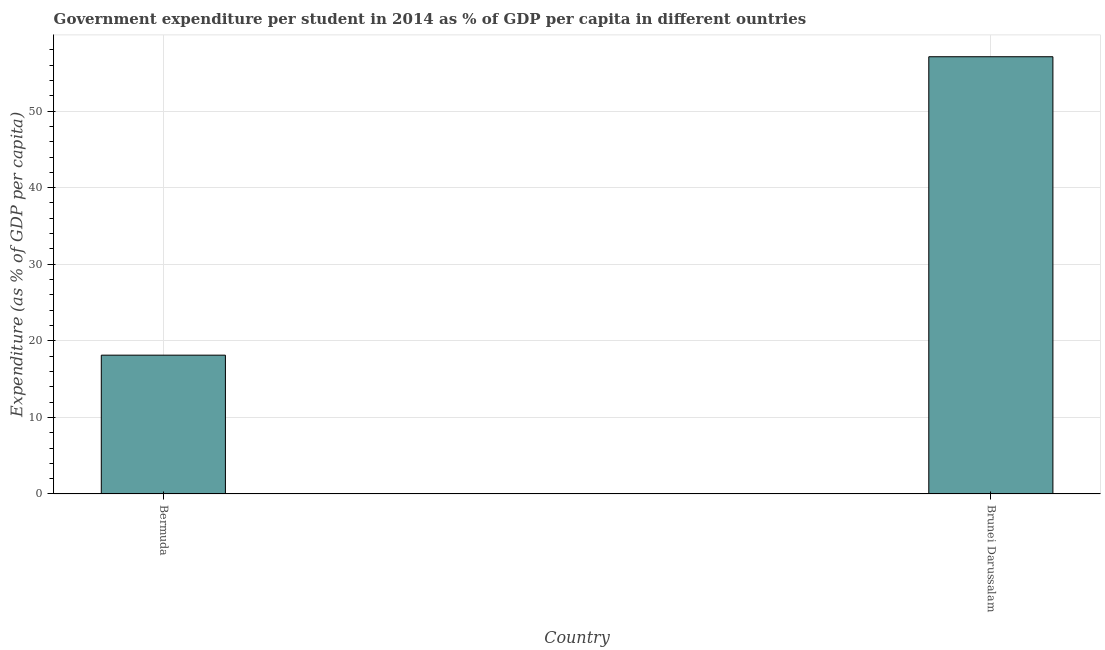Does the graph contain any zero values?
Your answer should be compact. No. What is the title of the graph?
Your response must be concise. Government expenditure per student in 2014 as % of GDP per capita in different ountries. What is the label or title of the Y-axis?
Offer a very short reply. Expenditure (as % of GDP per capita). What is the government expenditure per student in Brunei Darussalam?
Your response must be concise. 57.09. Across all countries, what is the maximum government expenditure per student?
Your answer should be very brief. 57.09. Across all countries, what is the minimum government expenditure per student?
Your response must be concise. 18.12. In which country was the government expenditure per student maximum?
Provide a short and direct response. Brunei Darussalam. In which country was the government expenditure per student minimum?
Keep it short and to the point. Bermuda. What is the sum of the government expenditure per student?
Make the answer very short. 75.22. What is the difference between the government expenditure per student in Bermuda and Brunei Darussalam?
Give a very brief answer. -38.97. What is the average government expenditure per student per country?
Your answer should be compact. 37.61. What is the median government expenditure per student?
Your answer should be very brief. 37.61. In how many countries, is the government expenditure per student greater than 14 %?
Your answer should be compact. 2. What is the ratio of the government expenditure per student in Bermuda to that in Brunei Darussalam?
Your answer should be very brief. 0.32. Is the government expenditure per student in Bermuda less than that in Brunei Darussalam?
Offer a terse response. Yes. How many bars are there?
Ensure brevity in your answer.  2. How many countries are there in the graph?
Your response must be concise. 2. Are the values on the major ticks of Y-axis written in scientific E-notation?
Give a very brief answer. No. What is the Expenditure (as % of GDP per capita) in Bermuda?
Give a very brief answer. 18.12. What is the Expenditure (as % of GDP per capita) of Brunei Darussalam?
Your response must be concise. 57.09. What is the difference between the Expenditure (as % of GDP per capita) in Bermuda and Brunei Darussalam?
Offer a terse response. -38.97. What is the ratio of the Expenditure (as % of GDP per capita) in Bermuda to that in Brunei Darussalam?
Give a very brief answer. 0.32. 